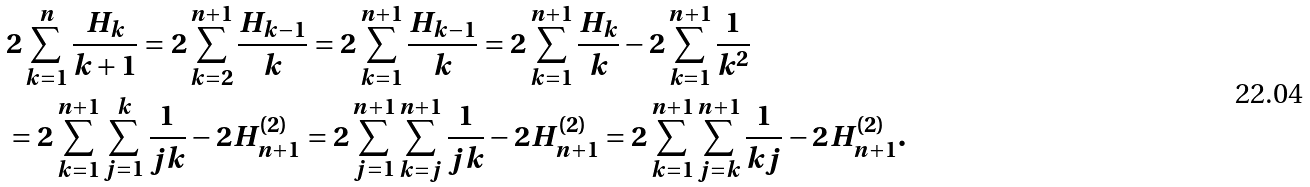<formula> <loc_0><loc_0><loc_500><loc_500>& 2 \sum _ { k = 1 } ^ { n } \frac { H _ { k } } { k + 1 } = 2 \sum _ { k = 2 } ^ { n + 1 } \frac { H _ { k - 1 } } { k } = 2 \sum _ { k = 1 } ^ { n + 1 } \frac { H _ { k - 1 } } { k } = 2 \sum _ { k = 1 } ^ { n + 1 } \frac { H _ { k } } { k } - 2 \sum _ { k = 1 } ^ { n + 1 } \frac { 1 } { k ^ { 2 } } \\ & = 2 \sum _ { k = 1 } ^ { n + 1 } \sum _ { j = 1 } ^ { k } \frac { 1 } { j k } - 2 H ^ { ( 2 ) } _ { n + 1 } = 2 \sum _ { j = 1 } ^ { n + 1 } \sum _ { k = j } ^ { n + 1 } \frac { 1 } { j k } - 2 H ^ { ( 2 ) } _ { n + 1 } = 2 \sum _ { k = 1 } ^ { n + 1 } \sum _ { j = k } ^ { n + 1 } \frac { 1 } { k j } - 2 H ^ { ( 2 ) } _ { n + 1 } .</formula> 